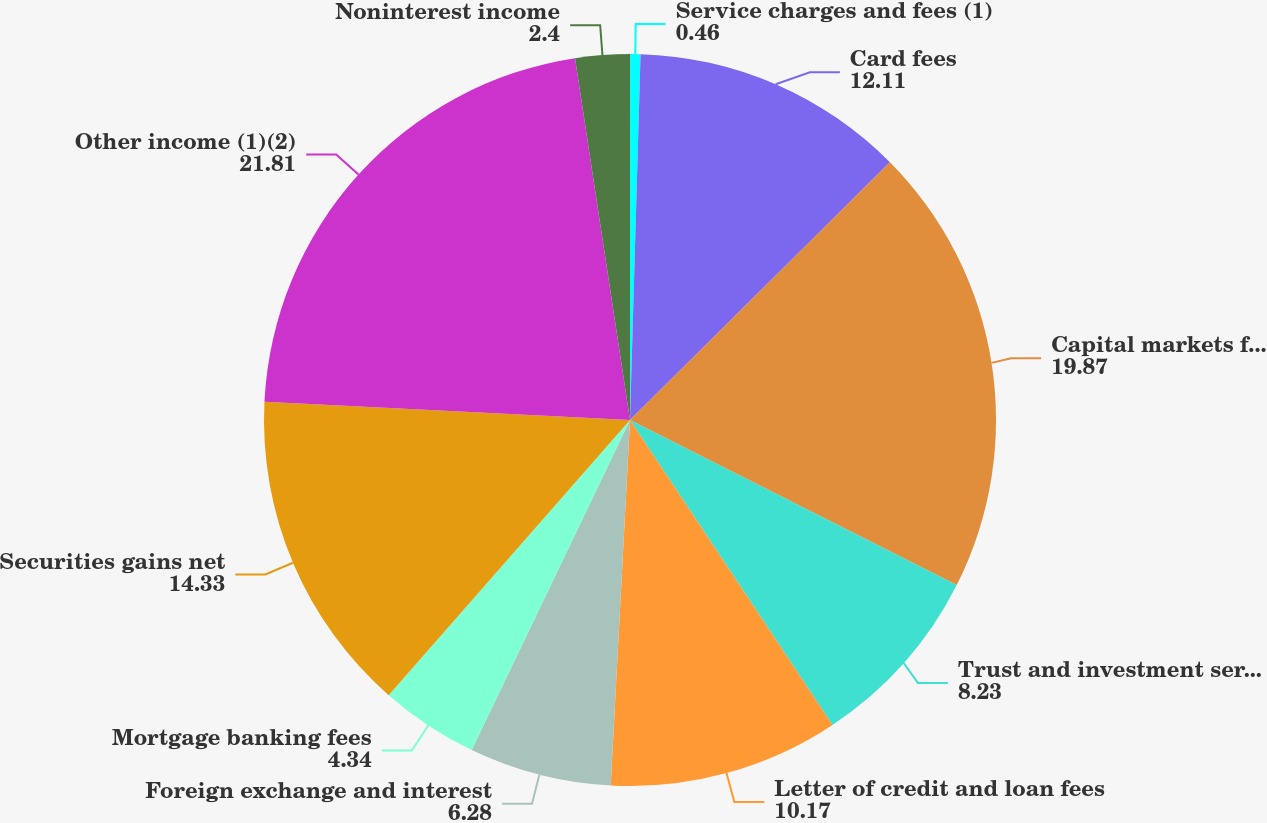Convert chart. <chart><loc_0><loc_0><loc_500><loc_500><pie_chart><fcel>Service charges and fees (1)<fcel>Card fees<fcel>Capital markets fees (1)<fcel>Trust and investment services<fcel>Letter of credit and loan fees<fcel>Foreign exchange and interest<fcel>Mortgage banking fees<fcel>Securities gains net<fcel>Other income (1)(2)<fcel>Noninterest income<nl><fcel>0.46%<fcel>12.11%<fcel>19.87%<fcel>8.23%<fcel>10.17%<fcel>6.28%<fcel>4.34%<fcel>14.33%<fcel>21.81%<fcel>2.4%<nl></chart> 